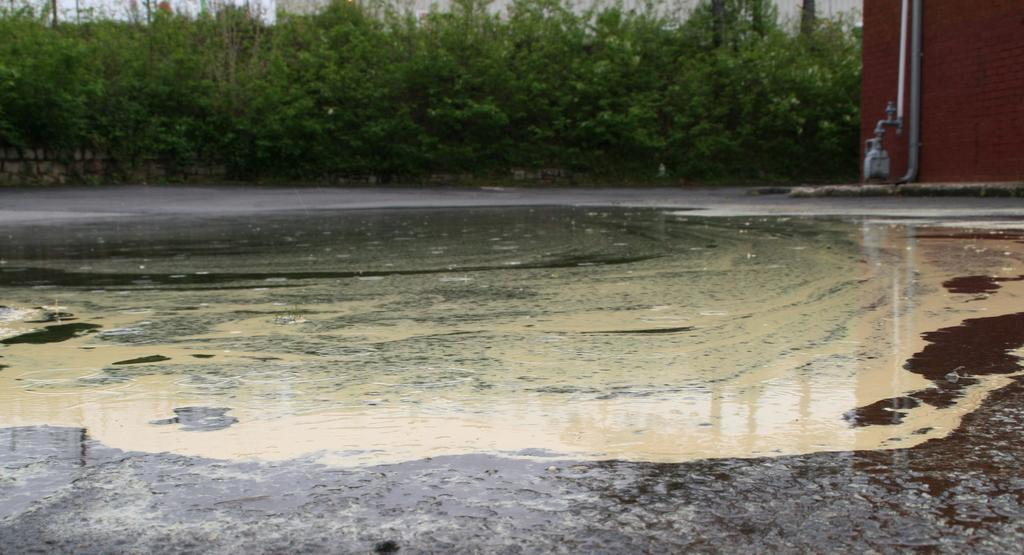What is covering the ground in the image? There is water on the ground in the image. What can be seen on the wall in the image? There is a wall with pipes in the image. What type of vegetation is present in the image? There is a group of plants in the image. Where is the station located in the image? There is no station present in the image. What type of machine is visible in the image? There is no machine visible in the image. 